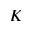<formula> <loc_0><loc_0><loc_500><loc_500>K</formula> 